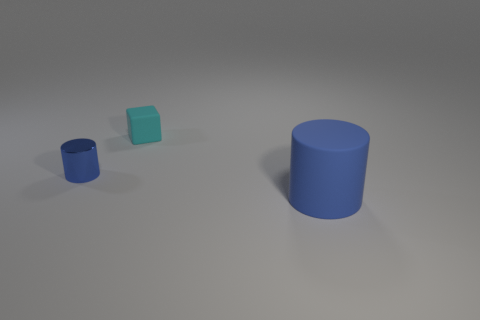Add 2 large yellow spheres. How many objects exist? 5 Subtract all cylinders. How many objects are left? 1 Subtract all small purple metal cylinders. Subtract all rubber things. How many objects are left? 1 Add 1 small blocks. How many small blocks are left? 2 Add 2 large rubber objects. How many large rubber objects exist? 3 Subtract 0 yellow balls. How many objects are left? 3 Subtract 1 cylinders. How many cylinders are left? 1 Subtract all brown cylinders. Subtract all green blocks. How many cylinders are left? 2 Subtract all red blocks. How many yellow cylinders are left? 0 